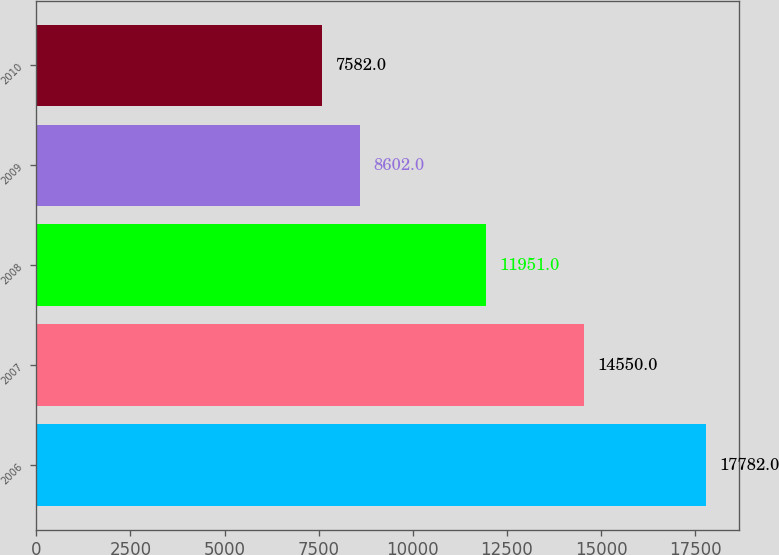Convert chart. <chart><loc_0><loc_0><loc_500><loc_500><bar_chart><fcel>2006<fcel>2007<fcel>2008<fcel>2009<fcel>2010<nl><fcel>17782<fcel>14550<fcel>11951<fcel>8602<fcel>7582<nl></chart> 